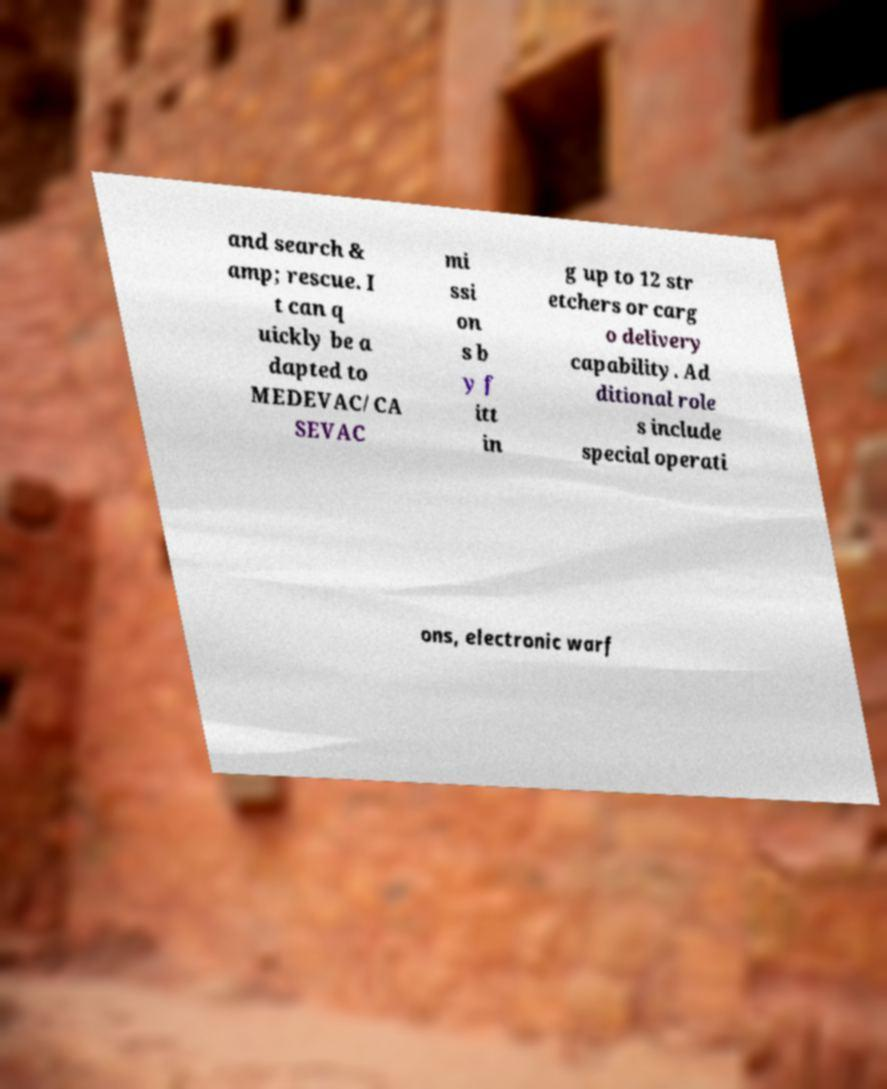What messages or text are displayed in this image? I need them in a readable, typed format. and search & amp; rescue. I t can q uickly be a dapted to MEDEVAC/CA SEVAC mi ssi on s b y f itt in g up to 12 str etchers or carg o delivery capability. Ad ditional role s include special operati ons, electronic warf 